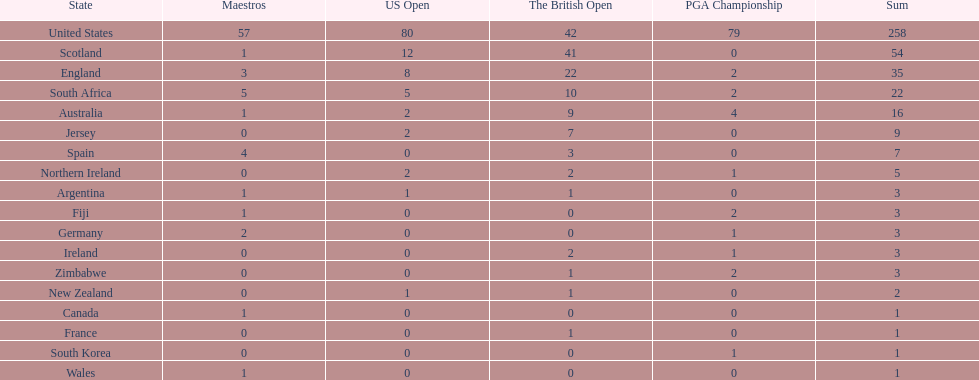In this table, which african country possesses the smallest number of champion golfers? Zimbabwe. I'm looking to parse the entire table for insights. Could you assist me with that? {'header': ['State', 'Maestros', 'US Open', 'The British Open', 'PGA Championship', 'Sum'], 'rows': [['United States', '57', '80', '42', '79', '258'], ['Scotland', '1', '12', '41', '0', '54'], ['England', '3', '8', '22', '2', '35'], ['South Africa', '5', '5', '10', '2', '22'], ['Australia', '1', '2', '9', '4', '16'], ['Jersey', '0', '2', '7', '0', '9'], ['Spain', '4', '0', '3', '0', '7'], ['Northern Ireland', '0', '2', '2', '1', '5'], ['Argentina', '1', '1', '1', '0', '3'], ['Fiji', '1', '0', '0', '2', '3'], ['Germany', '2', '0', '0', '1', '3'], ['Ireland', '0', '0', '2', '1', '3'], ['Zimbabwe', '0', '0', '1', '2', '3'], ['New Zealand', '0', '1', '1', '0', '2'], ['Canada', '1', '0', '0', '0', '1'], ['France', '0', '0', '1', '0', '1'], ['South Korea', '0', '0', '0', '1', '1'], ['Wales', '1', '0', '0', '0', '1']]} 